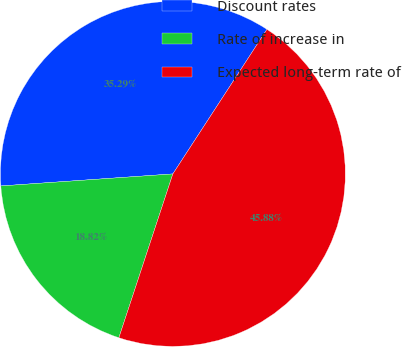<chart> <loc_0><loc_0><loc_500><loc_500><pie_chart><fcel>Discount rates<fcel>Rate of increase in<fcel>Expected long-term rate of<nl><fcel>35.29%<fcel>18.82%<fcel>45.88%<nl></chart> 